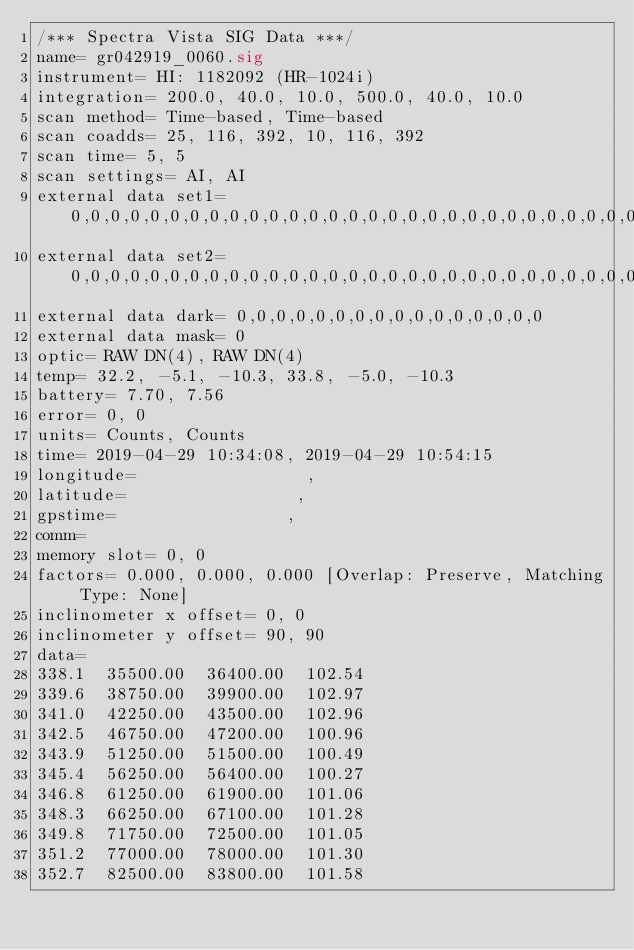Convert code to text. <code><loc_0><loc_0><loc_500><loc_500><_SML_>/*** Spectra Vista SIG Data ***/
name= gr042919_0060.sig
instrument= HI: 1182092 (HR-1024i)
integration= 200.0, 40.0, 10.0, 500.0, 40.0, 10.0
scan method= Time-based, Time-based
scan coadds= 25, 116, 392, 10, 116, 392
scan time= 5, 5
scan settings= AI, AI
external data set1= 0,0,0,0,0,0,0,0,0,0,0,0,0,0,0,0,0,0,0,0,0,0,0,0,0,0,0,0,0,0,0,0
external data set2= 0,0,0,0,0,0,0,0,0,0,0,0,0,0,0,0,0,0,0,0,0,0,0,0,0,0,0,0,0,0,0,0
external data dark= 0,0,0,0,0,0,0,0,0,0,0,0,0,0,0,0
external data mask= 0
optic= RAW DN(4), RAW DN(4)
temp= 32.2, -5.1, -10.3, 33.8, -5.0, -10.3
battery= 7.70, 7.56
error= 0, 0
units= Counts, Counts
time= 2019-04-29 10:34:08, 2019-04-29 10:54:15
longitude=                 ,                 
latitude=                 ,                 
gpstime=                 ,                 
comm= 
memory slot= 0, 0
factors= 0.000, 0.000, 0.000 [Overlap: Preserve, Matching Type: None]
inclinometer x offset= 0, 0
inclinometer y offset= 90, 90
data= 
338.1  35500.00  36400.00  102.54
339.6  38750.00  39900.00  102.97
341.0  42250.00  43500.00  102.96
342.5  46750.00  47200.00  100.96
343.9  51250.00  51500.00  100.49
345.4  56250.00  56400.00  100.27
346.8  61250.00  61900.00  101.06
348.3  66250.00  67100.00  101.28
349.8  71750.00  72500.00  101.05
351.2  77000.00  78000.00  101.30
352.7  82500.00  83800.00  101.58</code> 